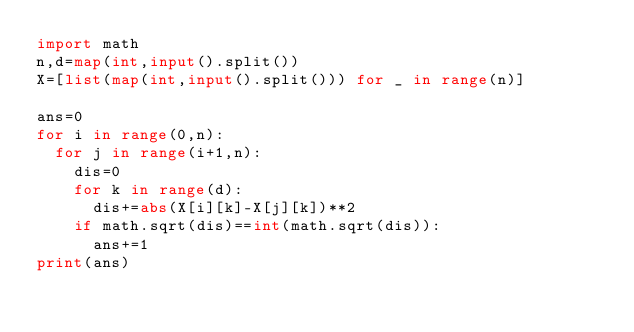Convert code to text. <code><loc_0><loc_0><loc_500><loc_500><_Python_>import math
n,d=map(int,input().split())
X=[list(map(int,input().split())) for _ in range(n)]

ans=0
for i in range(0,n):
  for j in range(i+1,n):
    dis=0
    for k in range(d):
      dis+=abs(X[i][k]-X[j][k])**2
    if math.sqrt(dis)==int(math.sqrt(dis)):
      ans+=1
print(ans)</code> 